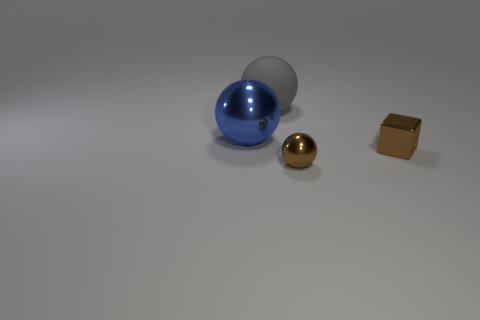Add 3 brown balls. How many objects exist? 7 Subtract all cubes. How many objects are left? 3 Add 1 tiny purple balls. How many tiny purple balls exist? 1 Subtract 0 red cylinders. How many objects are left? 4 Subtract all small brown blocks. Subtract all blue spheres. How many objects are left? 2 Add 3 tiny brown metallic objects. How many tiny brown metallic objects are left? 5 